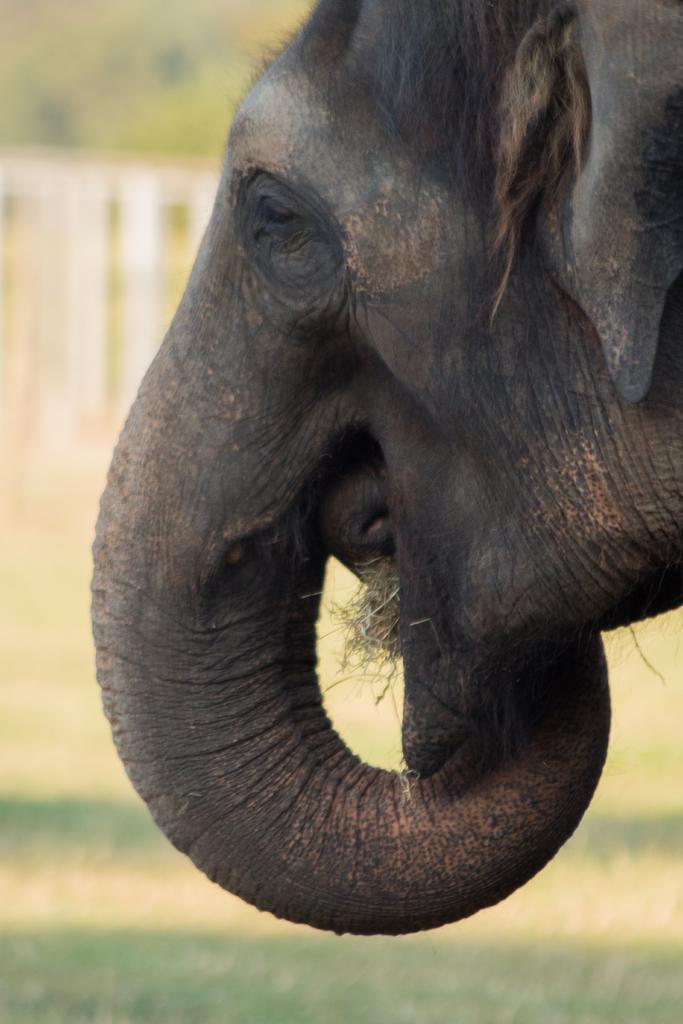What animal is present in the image? There is an elephant in the image. Which part of the elephant can be seen? Only the head part of the elephant is visible. How is the background of the image depicted? The background of the elephant is blurred. What type of trees can be seen in the background of the image? There are no trees visible in the background of the image; the background is blurred. 